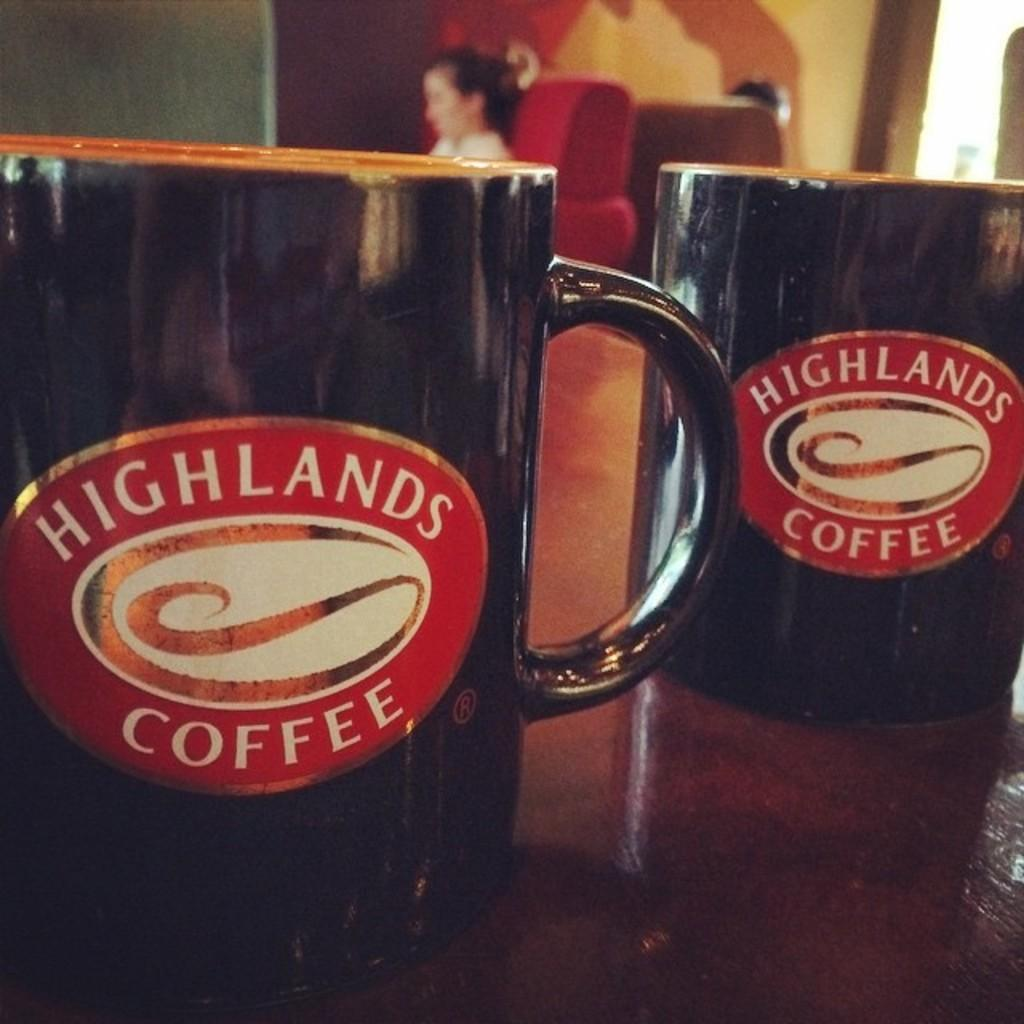<image>
Give a short and clear explanation of the subsequent image. a cup that has the words highlands coffee on it 